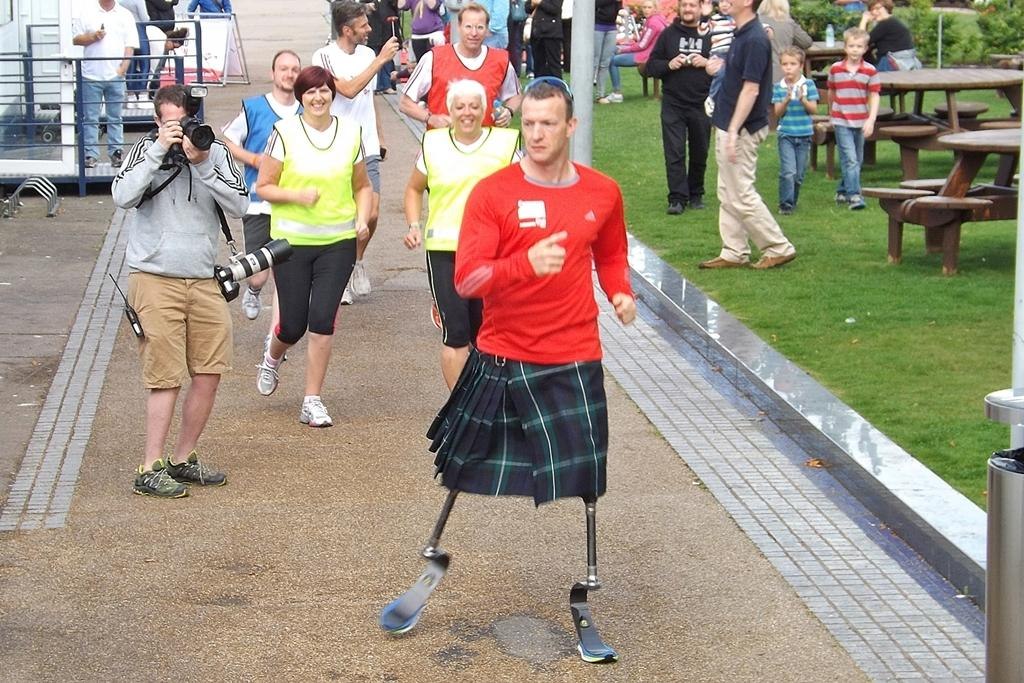What are the people in the image doing? There is a group of people running in the image. Can you describe the person who is not running? There is a person standing and taking a photograph with a camera. What type of seating is available in the image? There are benches in the image. Is there anyone in the image with a unique physical feature? Yes, there is a person running with artificial legs. What type of rock is being used as a breakfast table in the image? There is no rock or breakfast table present in the image. Can you tell me what the person with the camera is writing in the image? There is no indication that the person with the camera is writing anything in the image. 